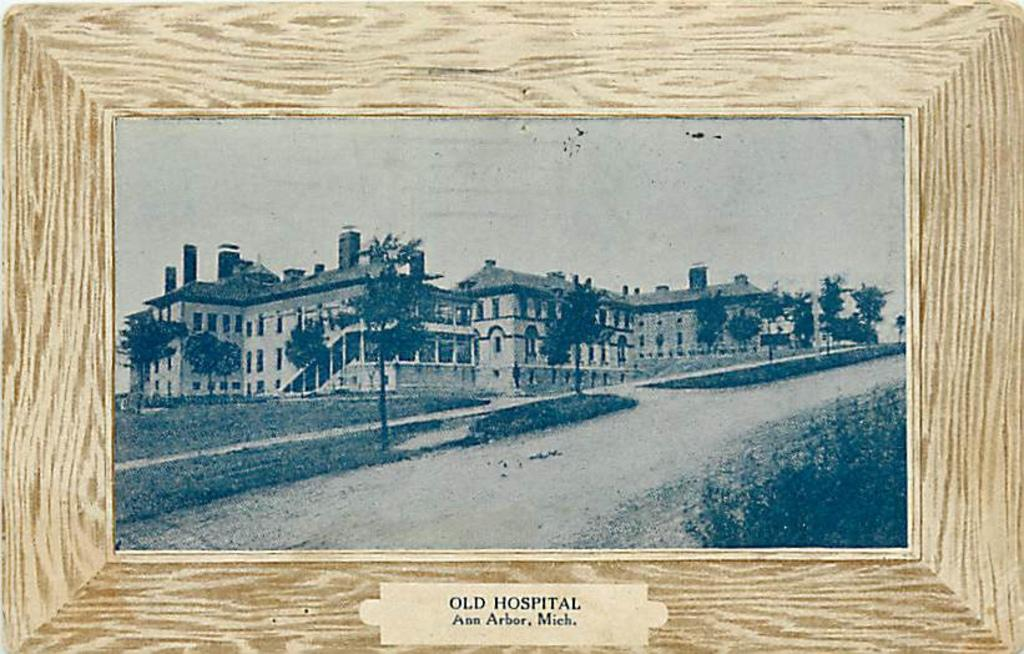<image>
Present a compact description of the photo's key features. A black and white framed photo of a building is labeled old hospital. 